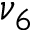Convert formula to latex. <formula><loc_0><loc_0><loc_500><loc_500>\nu _ { 6 }</formula> 